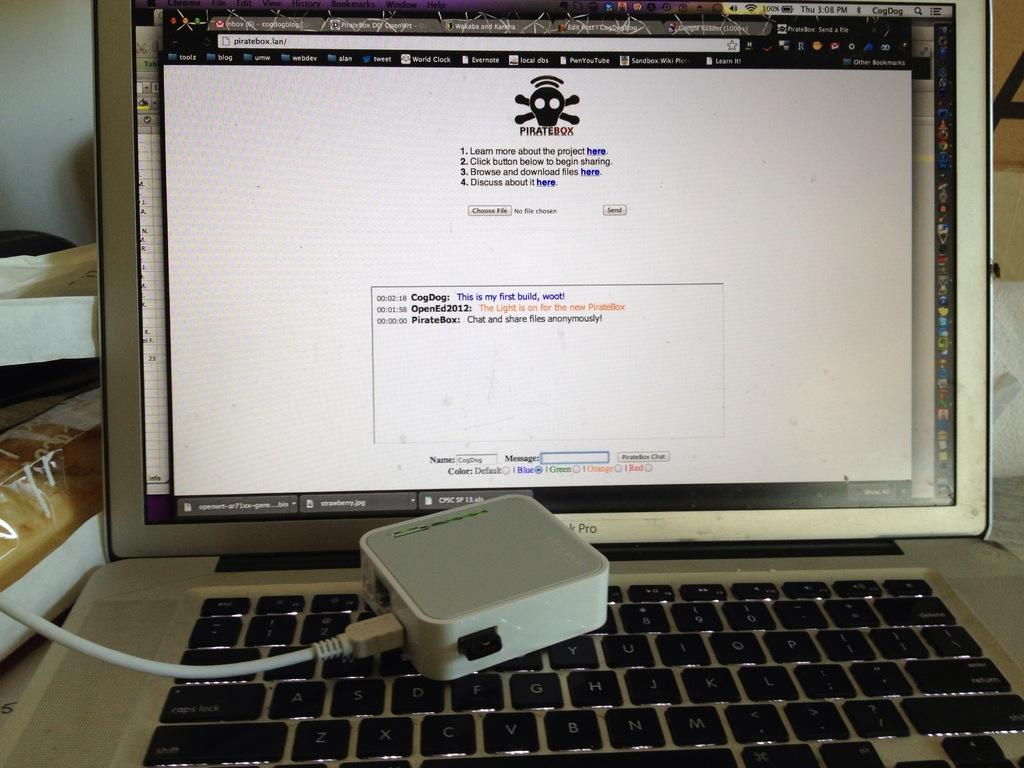Provide a one-sentence caption for the provided image. A MacBook Pro laptop open to the website piratebox.lan. 